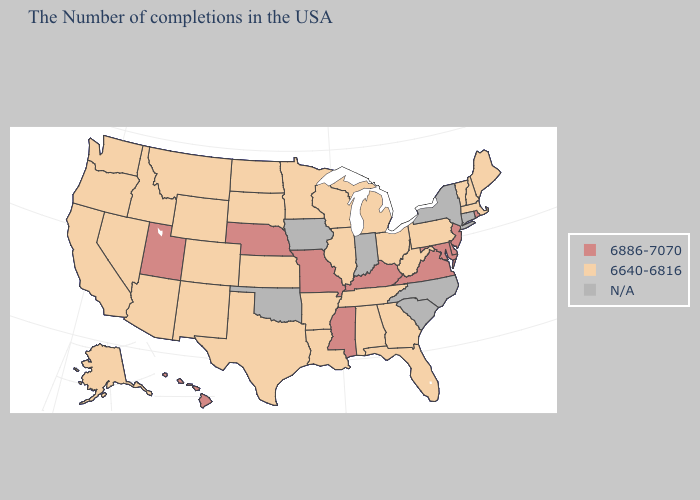Is the legend a continuous bar?
Be succinct. No. Name the states that have a value in the range 6886-7070?
Quick response, please. Rhode Island, New Jersey, Delaware, Maryland, Virginia, Kentucky, Mississippi, Missouri, Nebraska, Utah, Hawaii. What is the highest value in the USA?
Short answer required. 6886-7070. Name the states that have a value in the range 6886-7070?
Be succinct. Rhode Island, New Jersey, Delaware, Maryland, Virginia, Kentucky, Mississippi, Missouri, Nebraska, Utah, Hawaii. What is the highest value in the USA?
Keep it brief. 6886-7070. Among the states that border Iowa , does Nebraska have the highest value?
Be succinct. Yes. What is the value of New Jersey?
Write a very short answer. 6886-7070. What is the lowest value in states that border North Dakota?
Answer briefly. 6640-6816. Among the states that border North Dakota , which have the lowest value?
Give a very brief answer. Minnesota, South Dakota, Montana. Is the legend a continuous bar?
Give a very brief answer. No. Which states have the highest value in the USA?
Give a very brief answer. Rhode Island, New Jersey, Delaware, Maryland, Virginia, Kentucky, Mississippi, Missouri, Nebraska, Utah, Hawaii. What is the value of Vermont?
Answer briefly. 6640-6816. Does the map have missing data?
Keep it brief. Yes. What is the value of South Dakota?
Quick response, please. 6640-6816. 